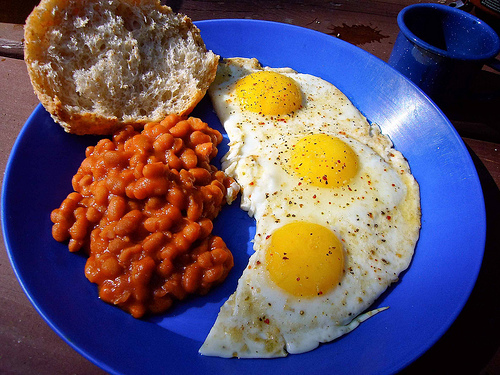<image>
Can you confirm if the eggs is to the left of the plate? No. The eggs is not to the left of the plate. From this viewpoint, they have a different horizontal relationship. 